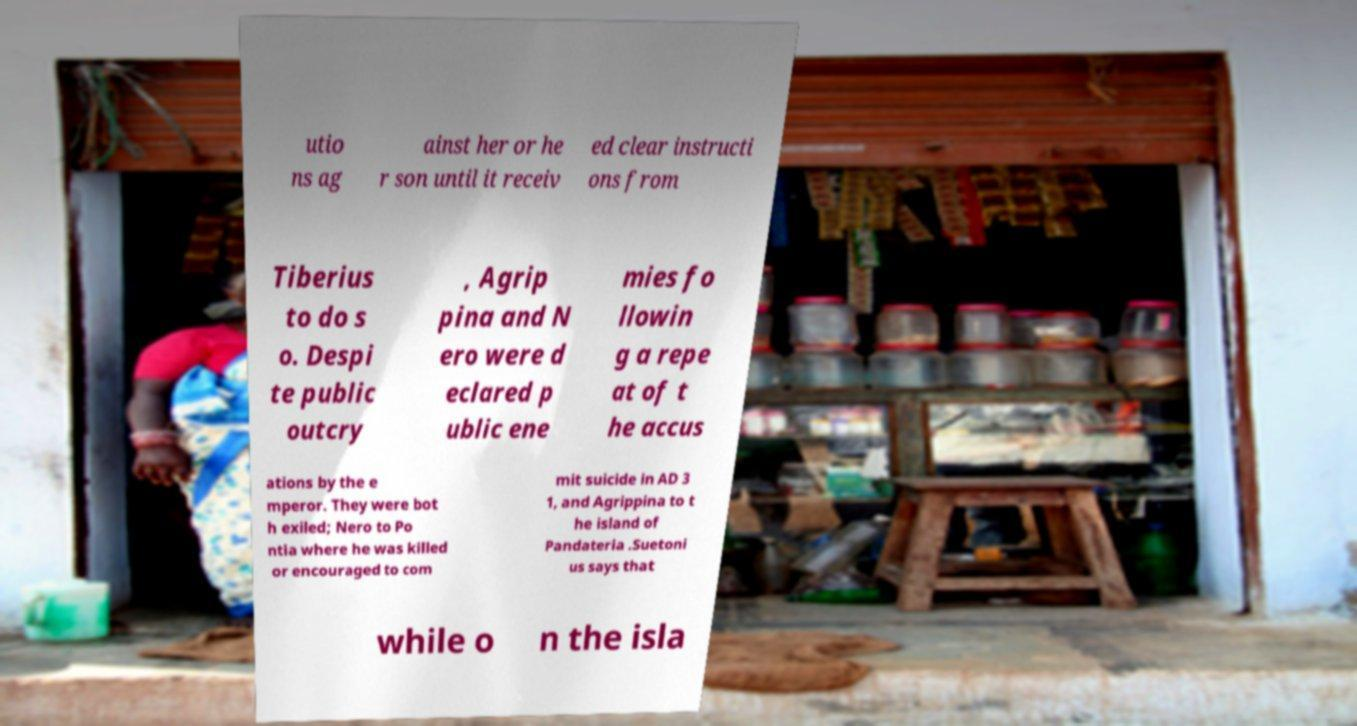There's text embedded in this image that I need extracted. Can you transcribe it verbatim? utio ns ag ainst her or he r son until it receiv ed clear instructi ons from Tiberius to do s o. Despi te public outcry , Agrip pina and N ero were d eclared p ublic ene mies fo llowin g a repe at of t he accus ations by the e mperor. They were bot h exiled; Nero to Po ntia where he was killed or encouraged to com mit suicide in AD 3 1, and Agrippina to t he island of Pandateria .Suetoni us says that while o n the isla 